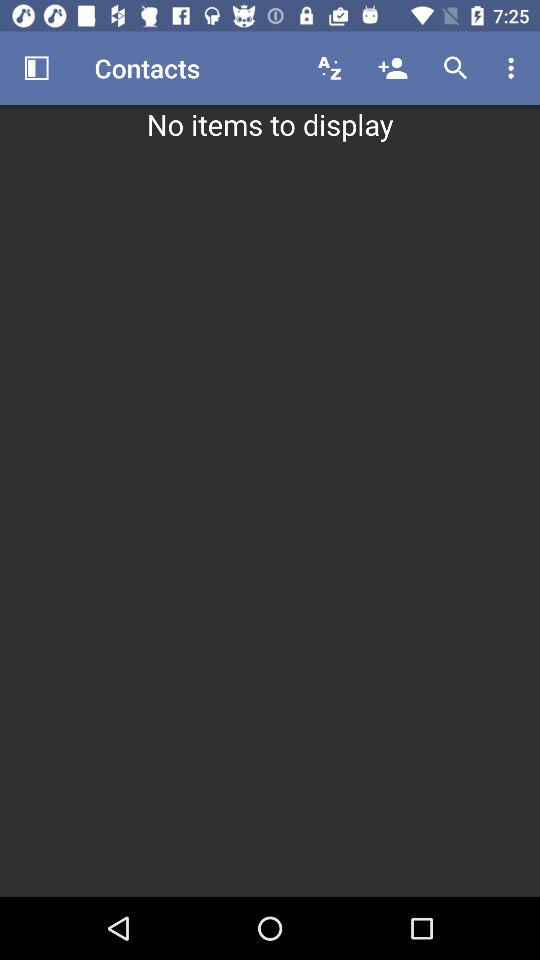Are there any items to display? There are no items to display. 